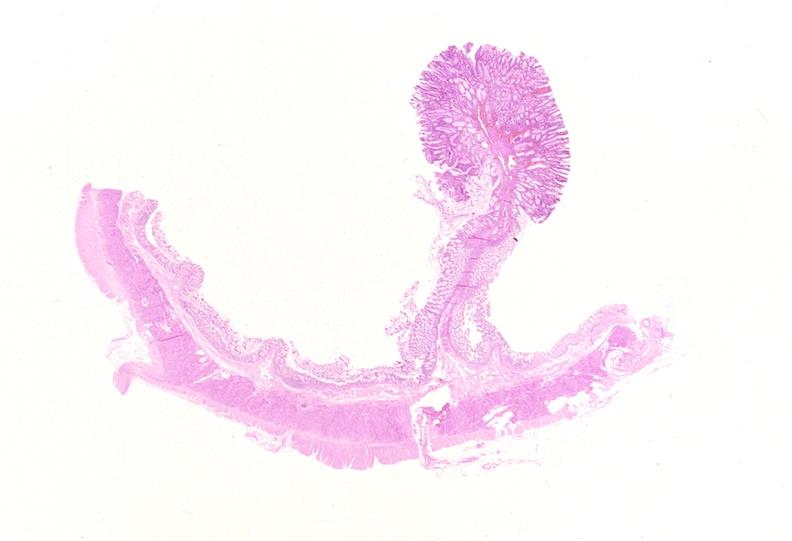s gastrointestinal present?
Answer the question using a single word or phrase. Yes 